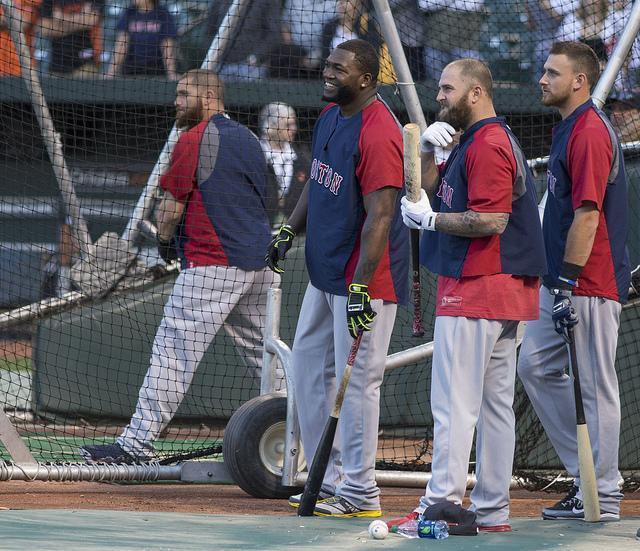How many people can be seen?
Give a very brief answer. 6. How many baseball bats are visible?
Give a very brief answer. 3. 